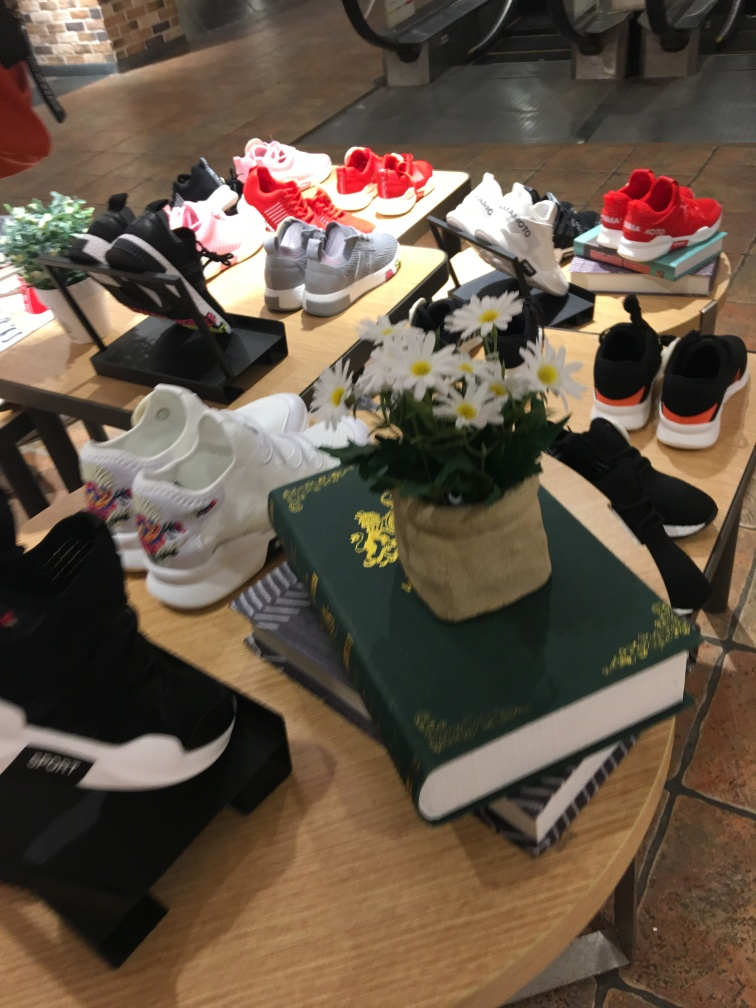What might be the setting or context of this image? The setting looks like a retail shoe store with a contemporary display. The arrangement of the shoes on stands and shelves, along with stacked books underneath, suggests a casual, trendy shopping environment aimed at fashion-conscious consumers. 